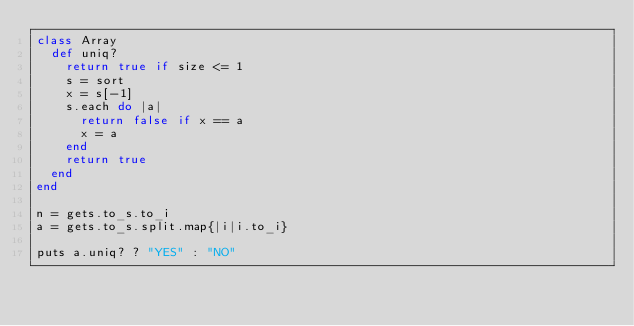Convert code to text. <code><loc_0><loc_0><loc_500><loc_500><_Ruby_>class Array
  def uniq?
    return true if size <= 1
    s = sort
    x = s[-1] 
    s.each do |a|
      return false if x == a
      x = a
    end
    return true
  end
end

n = gets.to_s.to_i
a = gets.to_s.split.map{|i|i.to_i}

puts a.uniq? ? "YES" : "NO"</code> 